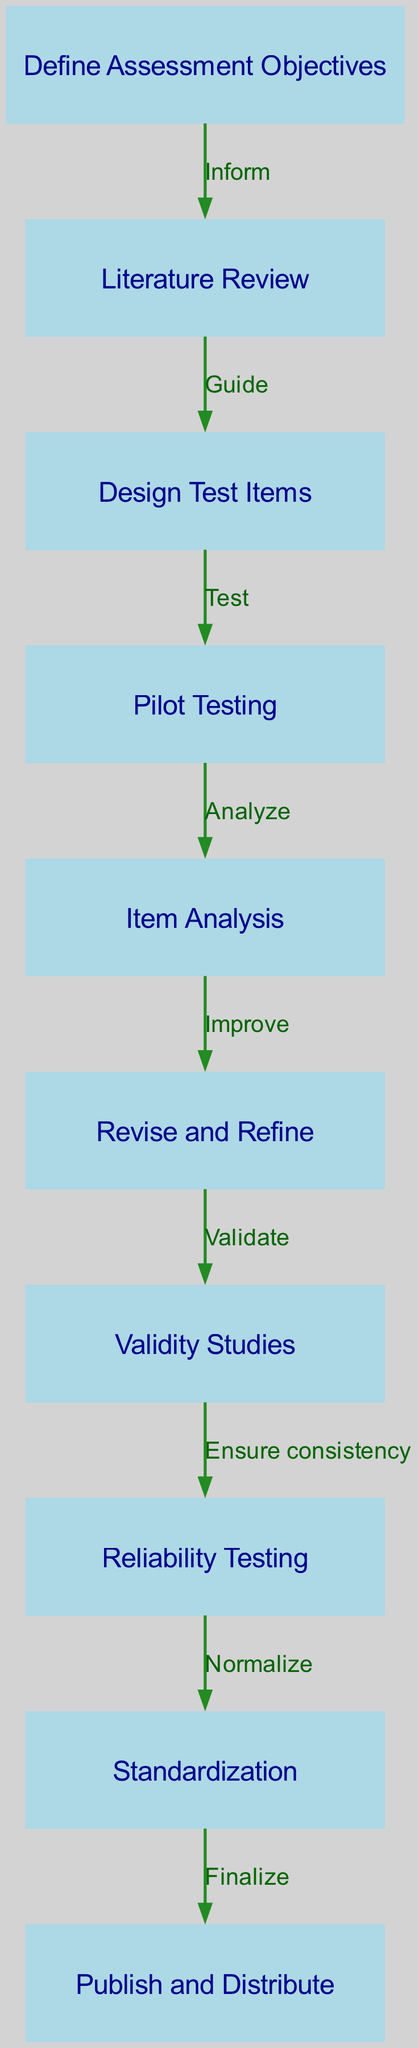What is the first step in the workflow? The first step listed in the diagram is "Define Assessment Objectives". This is the starting point indicated by the first node in the flow chart.
Answer: Define Assessment Objectives How many nodes are there in the diagram? By counting the distinct nodes listed in the data, there are 10 different nodes present in the workflow diagram.
Answer: 10 What is the relationship between "Pilot Testing" and "Item Analysis"? The relationship is defined by the edge connecting these two nodes, where "Pilot Testing" leads to "Item Analysis" with the label "Analyze". This indicates that after pilot testing, the next step is to analyze the items.
Answer: Analyze What is the last step in the workflow? The last step indicated in the workflow is "Publish and Distribute". This is the final node that concludes the assessment tool development process.
Answer: Publish and Distribute What stage follows "Revise and Refine"? The stage that follows "Revise and Refine" is "Validity Studies". The edge from the former to the latter shows the logical progression in the process.
Answer: Validity Studies How does the workflow ensure consistency? The workflow ensures consistency by performing "Reliability Testing" after conducting "Validity Studies". This shows a sequential process where both aspects of assessment quality are validated and tested.
Answer: Reliability Testing What is the purpose of the literature review in this workflow? The literature review serves as guidance for the next step, which is the design of test items. This indicates that prior research informs the development of the assessment tool.
Answer: Guide Which step comes before standardization? The step that comes before "Standardization" is "Reliability Testing". This sequence illustrates that testing consistency is a prerequisite for finalizing the assessment tool's metrics.
Answer: Reliability Testing 